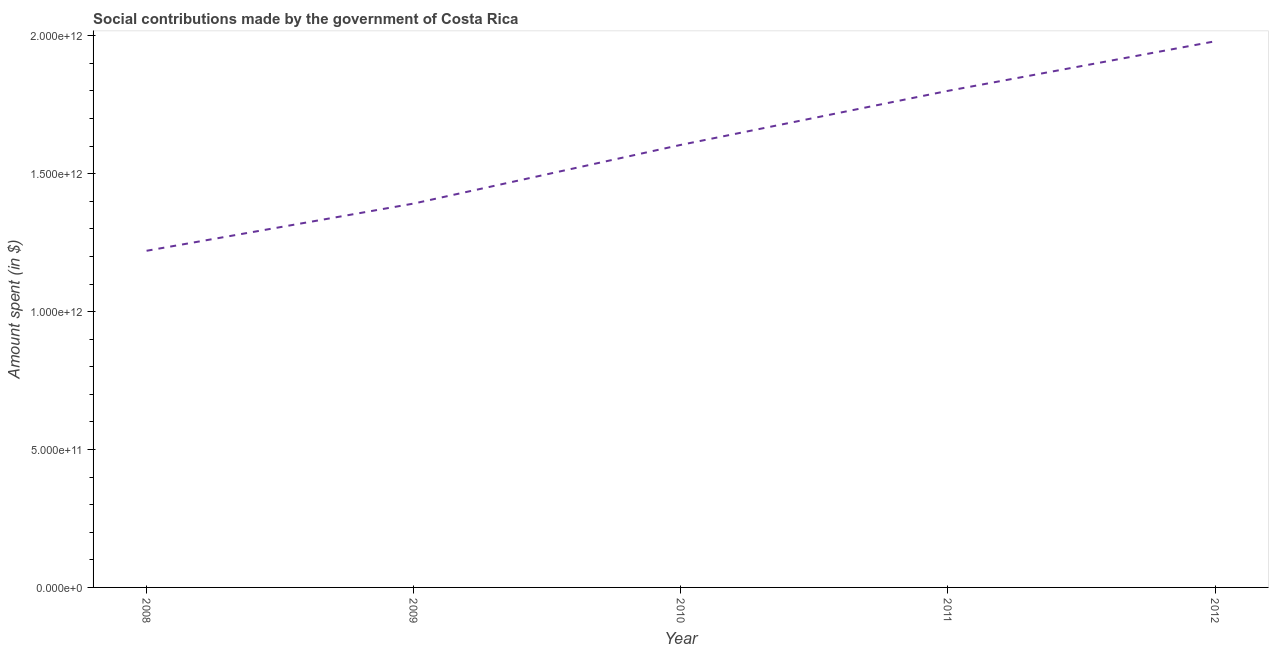What is the amount spent in making social contributions in 2010?
Your response must be concise. 1.60e+12. Across all years, what is the maximum amount spent in making social contributions?
Make the answer very short. 1.98e+12. Across all years, what is the minimum amount spent in making social contributions?
Provide a succinct answer. 1.22e+12. In which year was the amount spent in making social contributions minimum?
Your answer should be compact. 2008. What is the sum of the amount spent in making social contributions?
Offer a terse response. 8.00e+12. What is the difference between the amount spent in making social contributions in 2008 and 2009?
Offer a very short reply. -1.71e+11. What is the average amount spent in making social contributions per year?
Keep it short and to the point. 1.60e+12. What is the median amount spent in making social contributions?
Make the answer very short. 1.60e+12. Do a majority of the years between 2011 and 2008 (inclusive) have amount spent in making social contributions greater than 1100000000000 $?
Provide a succinct answer. Yes. What is the ratio of the amount spent in making social contributions in 2008 to that in 2010?
Offer a terse response. 0.76. Is the difference between the amount spent in making social contributions in 2010 and 2011 greater than the difference between any two years?
Provide a short and direct response. No. What is the difference between the highest and the second highest amount spent in making social contributions?
Provide a short and direct response. 1.80e+11. What is the difference between the highest and the lowest amount spent in making social contributions?
Make the answer very short. 7.60e+11. In how many years, is the amount spent in making social contributions greater than the average amount spent in making social contributions taken over all years?
Ensure brevity in your answer.  3. How many years are there in the graph?
Make the answer very short. 5. What is the difference between two consecutive major ticks on the Y-axis?
Ensure brevity in your answer.  5.00e+11. Does the graph contain any zero values?
Give a very brief answer. No. Does the graph contain grids?
Ensure brevity in your answer.  No. What is the title of the graph?
Your response must be concise. Social contributions made by the government of Costa Rica. What is the label or title of the X-axis?
Keep it short and to the point. Year. What is the label or title of the Y-axis?
Provide a short and direct response. Amount spent (in $). What is the Amount spent (in $) in 2008?
Make the answer very short. 1.22e+12. What is the Amount spent (in $) in 2009?
Keep it short and to the point. 1.39e+12. What is the Amount spent (in $) of 2010?
Keep it short and to the point. 1.60e+12. What is the Amount spent (in $) of 2011?
Offer a terse response. 1.80e+12. What is the Amount spent (in $) in 2012?
Ensure brevity in your answer.  1.98e+12. What is the difference between the Amount spent (in $) in 2008 and 2009?
Offer a terse response. -1.71e+11. What is the difference between the Amount spent (in $) in 2008 and 2010?
Ensure brevity in your answer.  -3.84e+11. What is the difference between the Amount spent (in $) in 2008 and 2011?
Keep it short and to the point. -5.80e+11. What is the difference between the Amount spent (in $) in 2008 and 2012?
Provide a short and direct response. -7.60e+11. What is the difference between the Amount spent (in $) in 2009 and 2010?
Give a very brief answer. -2.13e+11. What is the difference between the Amount spent (in $) in 2009 and 2011?
Your answer should be compact. -4.09e+11. What is the difference between the Amount spent (in $) in 2009 and 2012?
Your answer should be very brief. -5.88e+11. What is the difference between the Amount spent (in $) in 2010 and 2011?
Keep it short and to the point. -1.96e+11. What is the difference between the Amount spent (in $) in 2010 and 2012?
Make the answer very short. -3.76e+11. What is the difference between the Amount spent (in $) in 2011 and 2012?
Ensure brevity in your answer.  -1.80e+11. What is the ratio of the Amount spent (in $) in 2008 to that in 2009?
Your answer should be very brief. 0.88. What is the ratio of the Amount spent (in $) in 2008 to that in 2010?
Your response must be concise. 0.76. What is the ratio of the Amount spent (in $) in 2008 to that in 2011?
Provide a succinct answer. 0.68. What is the ratio of the Amount spent (in $) in 2008 to that in 2012?
Provide a short and direct response. 0.62. What is the ratio of the Amount spent (in $) in 2009 to that in 2010?
Ensure brevity in your answer.  0.87. What is the ratio of the Amount spent (in $) in 2009 to that in 2011?
Your answer should be compact. 0.77. What is the ratio of the Amount spent (in $) in 2009 to that in 2012?
Offer a very short reply. 0.7. What is the ratio of the Amount spent (in $) in 2010 to that in 2011?
Keep it short and to the point. 0.89. What is the ratio of the Amount spent (in $) in 2010 to that in 2012?
Make the answer very short. 0.81. What is the ratio of the Amount spent (in $) in 2011 to that in 2012?
Your response must be concise. 0.91. 